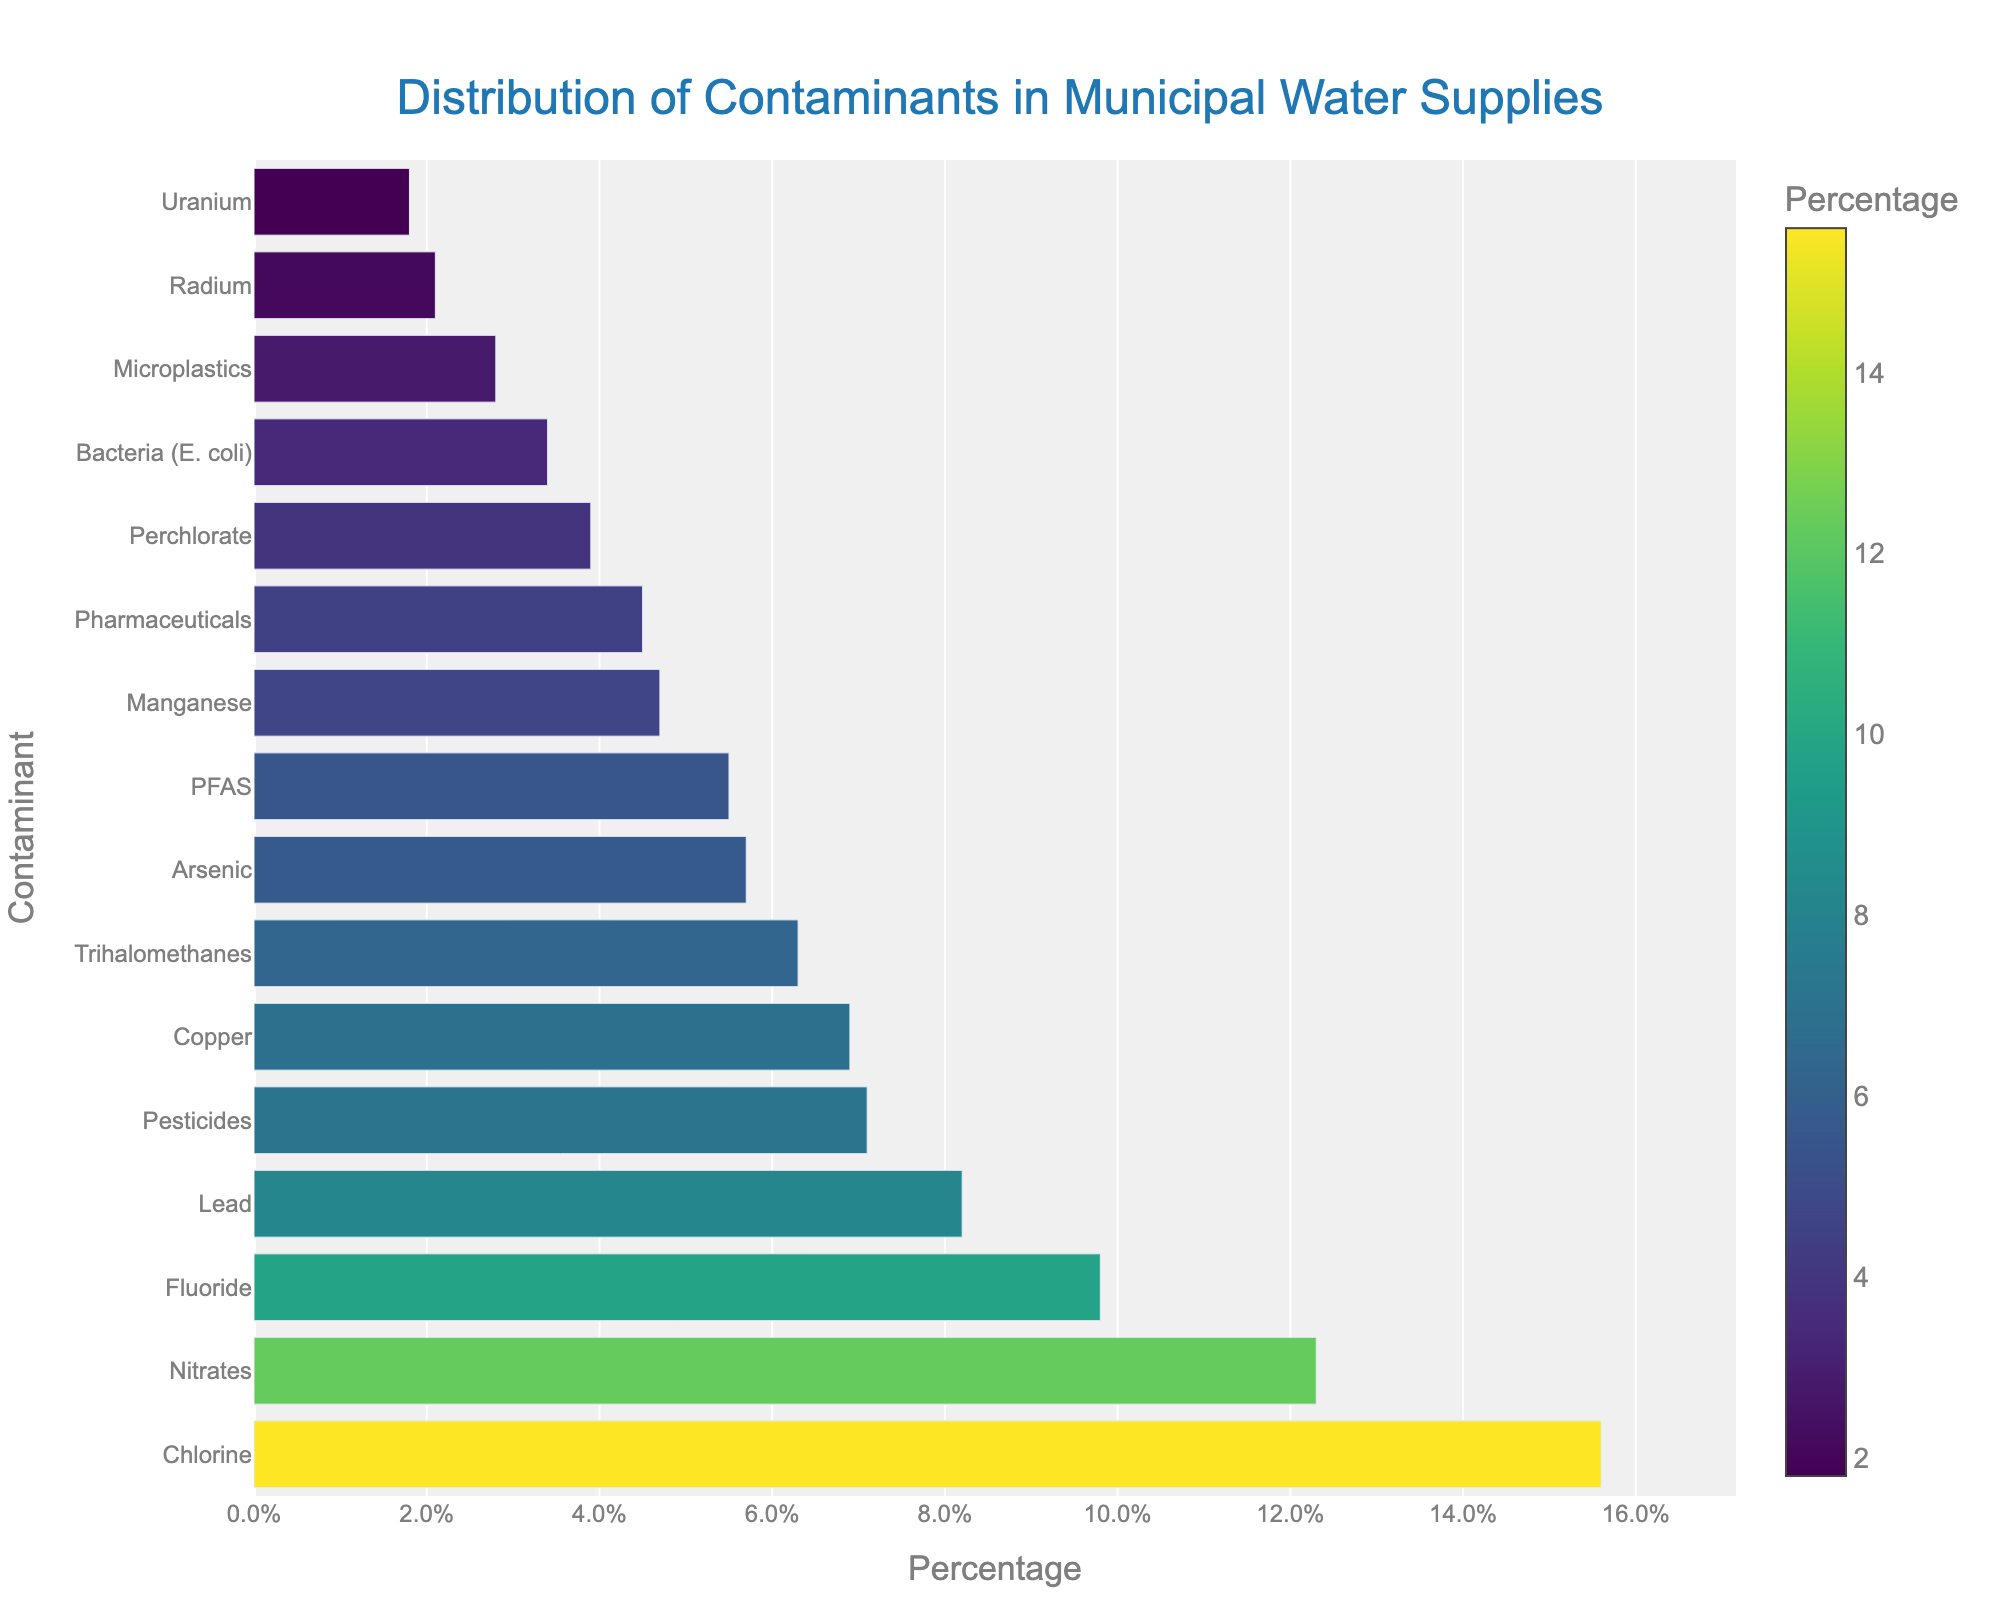Which contaminant has the highest percentage in municipal water supplies? The bar chart visually represents the contaminants found in municipal water supplies, and the contaminant with the longest bar indicates the highest percentage. Chlorine has the longest bar.
Answer: Chlorine Which contaminants have a percentage over 10%? By examining the length of the bars and their corresponding values on the x-axis, we can identify the contaminants with percentages over 10%. These bars will extend beyond the 10% mark on the x-axis.
Answer: Nitrates, Chlorine What's the combined percentage of Lead and Arsenic? Add the percentages of Lead (8.2%) and Arsenic (5.7%) by referring to the bar lengths and their respective values.
Answer: 13.9% How much higher is the percentage of Nitrates compared to Pesticides? Find the bar length for Nitrates (12.3%) and Pesticides (7.1%), then subtract the Pesticides percentage from the Nitrates percentage.
Answer: 5.2% Which has a lower percentage: Pharmaceuticals or PFAS? Compare the lengths of the bars for Pharmaceuticals (4.5%) and PFAS (5.5%). The bar for Pharmaceuticals is shorter.
Answer: Pharmaceuticals What is the total percentage of contaminants presented in the chart? Sum all the percentage values given for each contaminant. This involves adding each bar's length as indicated on the x-axis. Total = 8.2 + 5.7 + 12.3 + 15.6 + 6.9 + 9.8 + 3.4 + 7.1 + 4.5 + 2.8 + 6.3 + 3.9 + 2.1 + 5.5 + 4.7 + 1.8
Answer: 100% Which contaminant is represented by the bar with the darkest color? The color intensity in the chart correlates with the percentage. The bar with the highest percentage will have the darkest color. Chlorine is depicted with the darkest color since it has the highest percentage.
Answer: Chlorine How does the percentage of Copper compare to Fluoride? Compare the bar lengths for Copper (6.9%) and Fluoride (9.8%). The bar for Fluoride is longer than Copper.
Answer: Fluoride is higher What's the average percentage of the four highest contaminants? Identify the four highest percentages (Chlorine, Nitrates, Fluoride, Lead), sum their percentages, and divide by 4. Average = (15.6 + 12.3 + 9.8 + 8.2) / 4
Answer: 11.475% Which contaminants have a percentage below 5%? Identify the contaminants with bar lengths below the 5% mark. These are Bacteria (E. coli), Pharmaceuticals, Microplastics, Perchlorate, Radium, Uranium.
Answer: Bacteria (E. coli), Pharmaceuticals, Microplastics, Perchlorate, Radium, Uranium 